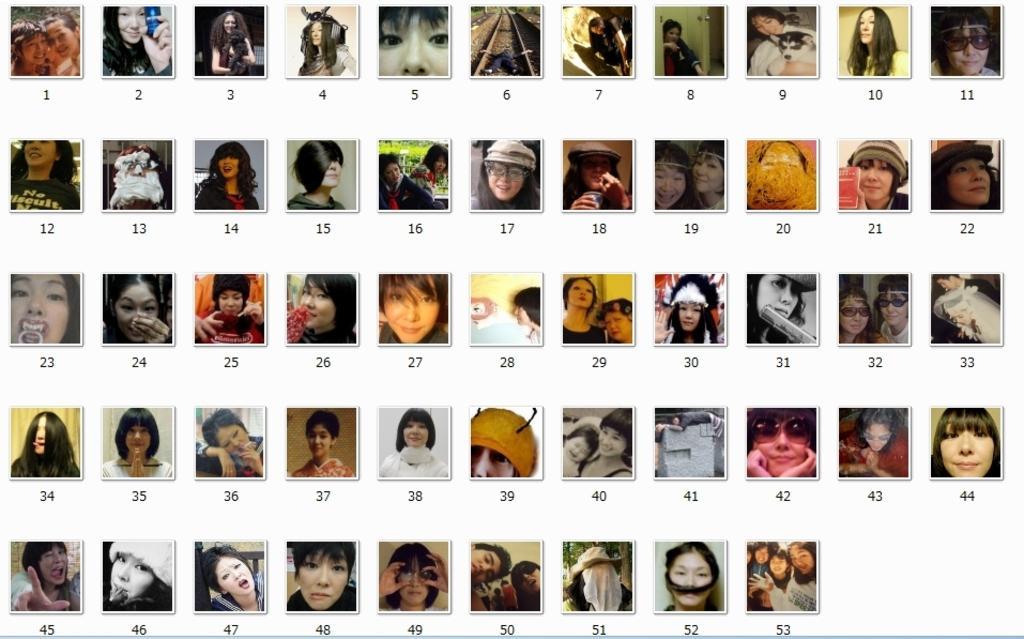Could you give a brief overview of what you see in this image? Here this picture consists of number of images of women with different facial expressions present. 